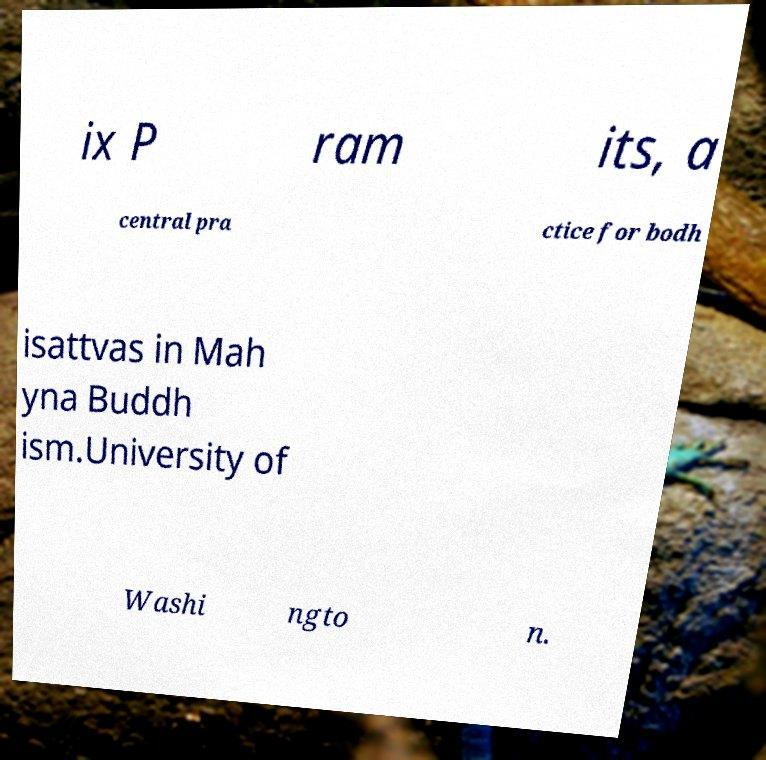There's text embedded in this image that I need extracted. Can you transcribe it verbatim? ix P ram its, a central pra ctice for bodh isattvas in Mah yna Buddh ism.University of Washi ngto n. 